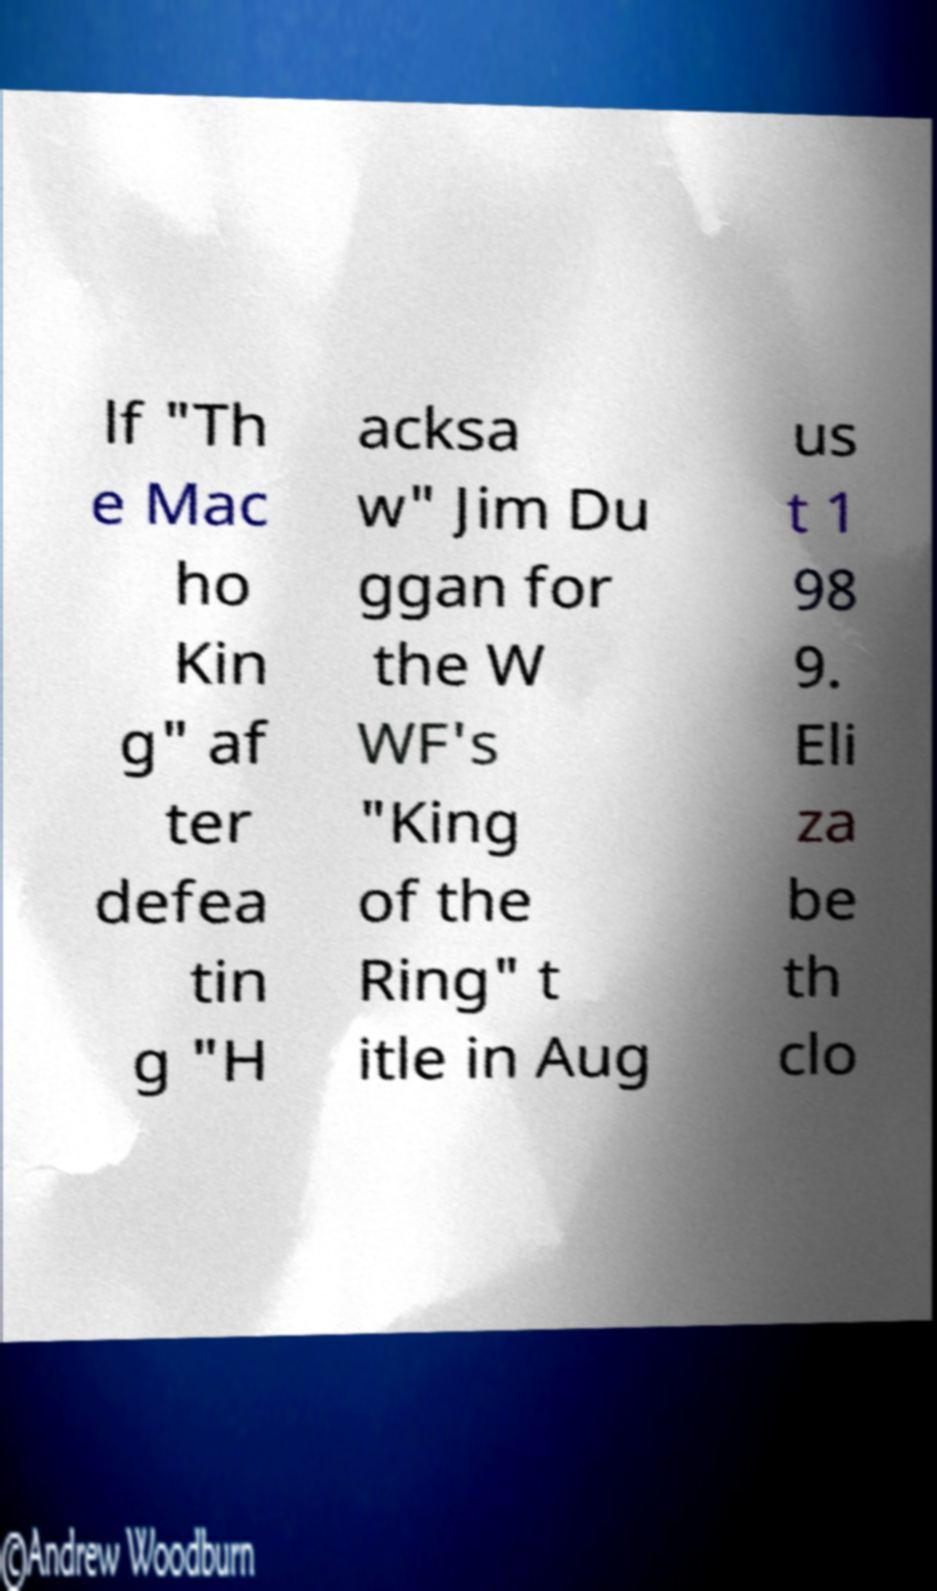There's text embedded in this image that I need extracted. Can you transcribe it verbatim? lf "Th e Mac ho Kin g" af ter defea tin g "H acksa w" Jim Du ggan for the W WF's "King of the Ring" t itle in Aug us t 1 98 9. Eli za be th clo 